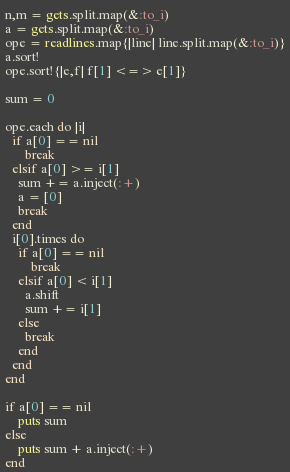<code> <loc_0><loc_0><loc_500><loc_500><_Ruby_>n,m = gets.split.map(&:to_i)
a = gets.split.map(&:to_i)
ope = readlines.map{|line| line.split.map(&:to_i)}
a.sort!
ope.sort!{|e,f| f[1] <=> e[1]}

sum = 0

ope.each do |i|
  if a[0] == nil
      break
  elsif a[0] >= i[1]
    sum += a.inject(:+)
    a = [0]
    break
  end
  i[0].times do
    if a[0] == nil
        break
    elsif a[0] < i[1]
      a.shift
      sum += i[1]
    else
      break
    end
  end
end

if a[0] == nil
    puts sum
else
    puts sum + a.inject(:+)
end</code> 